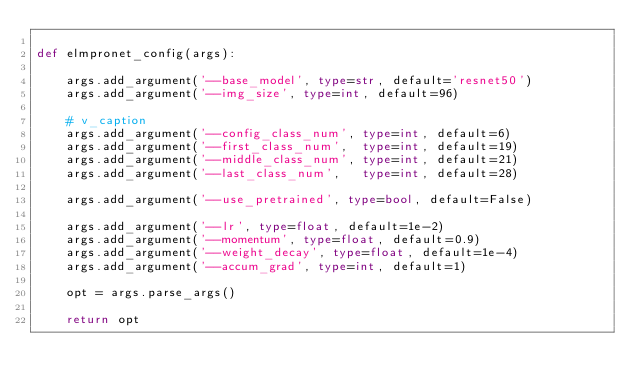<code> <loc_0><loc_0><loc_500><loc_500><_Python_>
def elmpronet_config(args):

    args.add_argument('--base_model', type=str, default='resnet50')
    args.add_argument('--img_size', type=int, default=96)

    # v_caption
    args.add_argument('--config_class_num', type=int, default=6)
    args.add_argument('--first_class_num',  type=int, default=19)
    args.add_argument('--middle_class_num', type=int, default=21)
    args.add_argument('--last_class_num',   type=int, default=28)

    args.add_argument('--use_pretrained', type=bool, default=False)

    args.add_argument('--lr', type=float, default=1e-2)
    args.add_argument('--momentum', type=float, default=0.9)
    args.add_argument('--weight_decay', type=float, default=1e-4)
    args.add_argument('--accum_grad', type=int, default=1)

    opt = args.parse_args()

    return opt</code> 